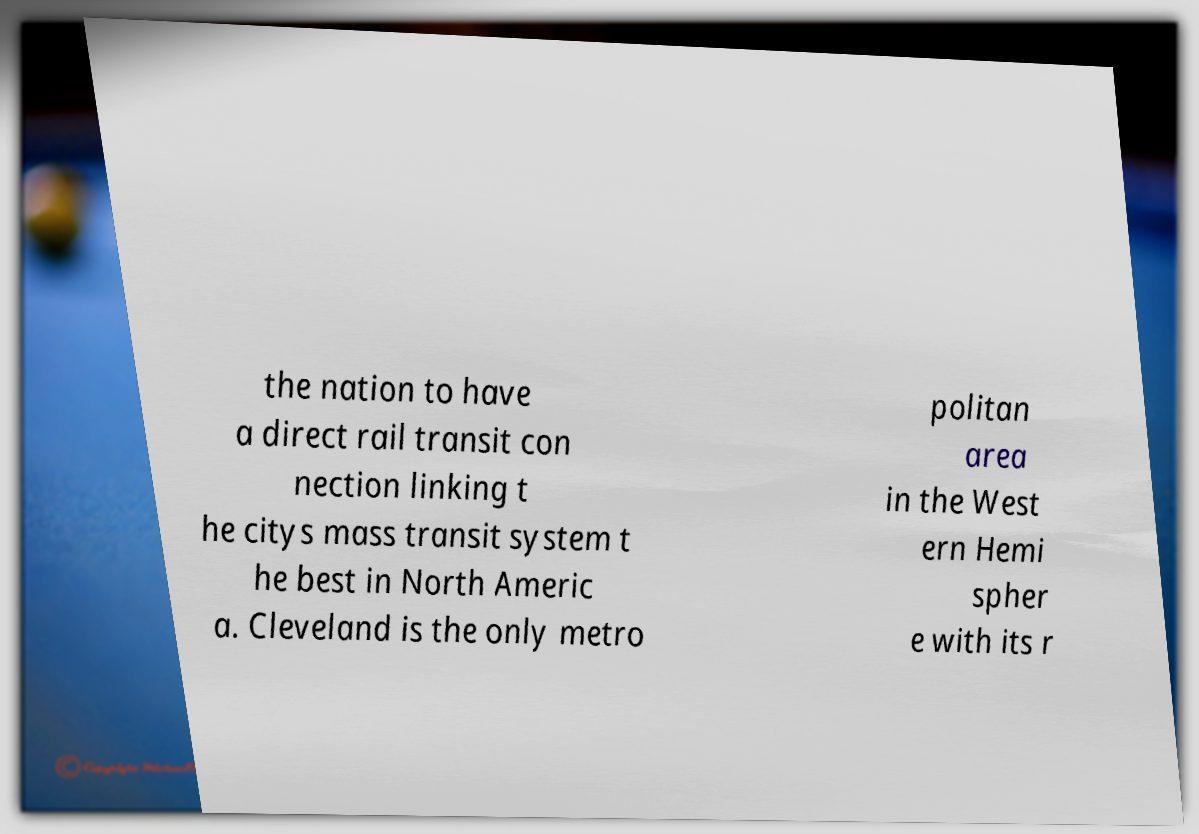Please read and relay the text visible in this image. What does it say? the nation to have a direct rail transit con nection linking t he citys mass transit system t he best in North Americ a. Cleveland is the only metro politan area in the West ern Hemi spher e with its r 